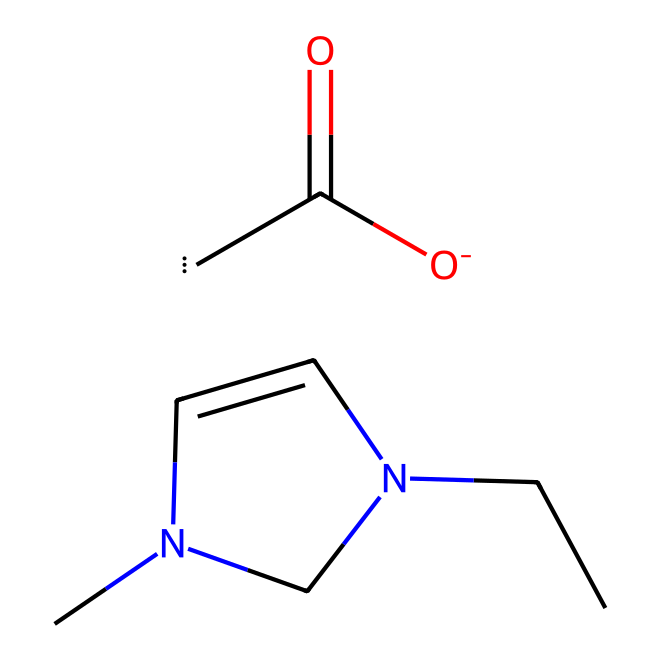What is the molecular formula of 1-ethyl-3-methylimidazolium acetate? To determine the molecular formula, count the unique atoms in the compound based on the SMILES structure. It includes two ethyl carbon atoms, two methyl carbon atoms, one nitrogen atom in the imidazolium structure, two oxygen atoms for the acetate, and additional hydrogens. The resulting formula is C8H13N2O2.
Answer: C8H13N2O2 How many nitrogen atoms are present in the structure? Inspect the SMILES representation for nitrogen atoms. The imidazolium ring shows one nitrogen directly in the backbone of the structure, confirming there is one nitrogen atom.
Answer: 2 What type of ionic liquid is represented by this compound? Analyze the structure, which includes an imidazolium cation and an acetate anion. This combination indicates that it is a type of ionic liquid due to the presence of both cationic and anionic components.
Answer: Imidazolium acetate How many atoms are there in total within the molecule? Count all individual atoms present in the structure: there are 8 carbons, 13 hydrogens, 2 nitrogens, and 2 oxygens, which sums to 25 atoms in total.
Answer: 25 What functional group is present in the ionic liquid? The acetate part of the molecule is characterized by a carbonyl group (C=O) and an oxygen atom bonded to a carbon chain, representing the ester group within the acetate ion connected to the imidazolium cation.
Answer: Acetate What is the role of the imidazolium cation in this ionic liquid? The imidazolium cation provides the necessary positive charge and stability within the structure, enabling dissolution properties and influencing the ionic liquid's overall characteristics such as viscosity and solubility, especially when interacting with cellulose.
Answer: Solvent properties 